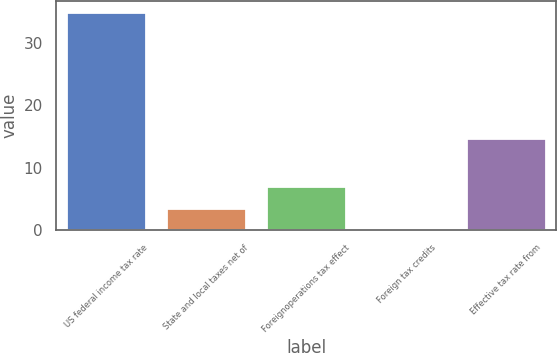Convert chart to OTSL. <chart><loc_0><loc_0><loc_500><loc_500><bar_chart><fcel>US federal income tax rate<fcel>State and local taxes net of<fcel>Foreignoperations tax effect<fcel>Foreign tax credits<fcel>Effective tax rate from<nl><fcel>35<fcel>3.59<fcel>7.08<fcel>0.1<fcel>14.7<nl></chart> 